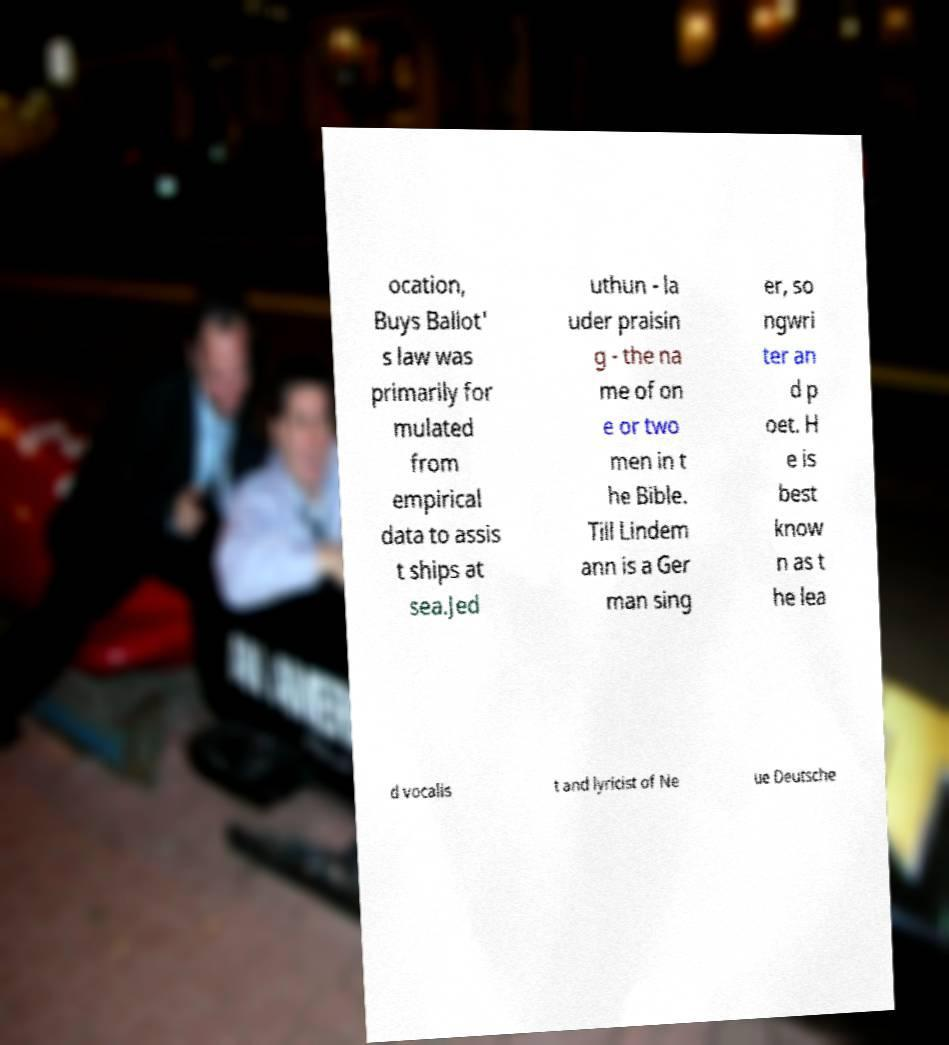Please identify and transcribe the text found in this image. ocation, Buys Ballot' s law was primarily for mulated from empirical data to assis t ships at sea.Jed uthun - la uder praisin g - the na me of on e or two men in t he Bible. Till Lindem ann is a Ger man sing er, so ngwri ter an d p oet. H e is best know n as t he lea d vocalis t and lyricist of Ne ue Deutsche 